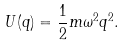<formula> <loc_0><loc_0><loc_500><loc_500>U ( q ) = \frac { 1 } { 2 } m \omega ^ { 2 } q ^ { 2 } .</formula> 